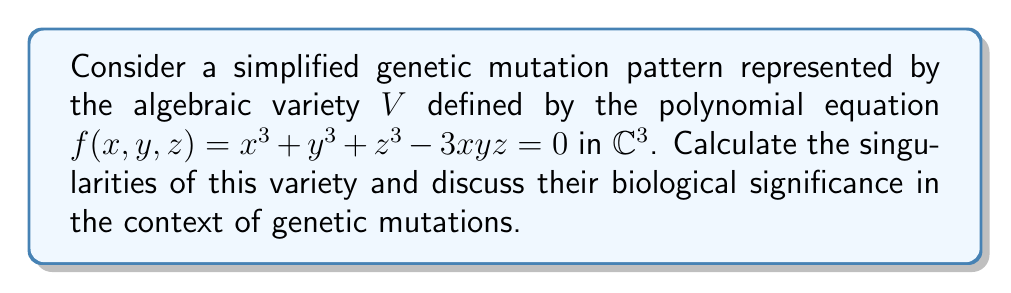Can you solve this math problem? To find the singularities of the algebraic variety $V$, we need to follow these steps:

1) Calculate the partial derivatives of $f(x,y,z)$:
   $$\frac{\partial f}{\partial x} = 3x^2 - 3yz$$
   $$\frac{\partial f}{\partial y} = 3y^2 - 3xz$$
   $$\frac{\partial f}{\partial z} = 3z^2 - 3xy$$

2) Set all partial derivatives equal to zero and solve the system of equations:
   $$3x^2 - 3yz = 0$$
   $$3y^2 - 3xz = 0$$
   $$3z^2 - 3xy = 0$$

3) Simplify the equations:
   $$x^2 = yz$$
   $$y^2 = xz$$
   $$z^2 = xy$$

4) Solve this system of equations:
   - If any of $x$, $y$, or $z$ is zero, then all must be zero to satisfy the equations.
   - If none are zero, then from $x^2 = yz$ and $z^2 = xy$, we get $x^3 = xyz$.
   - Substituting this into the original equation:
     $$x^3 + y^3 + z^3 - 3xyz = 0$$
     $$xyz + y^3 + z^3 - 3xyz = 0$$
     $$y^3 + z^3 - 2xyz = 0$$
   - Dividing by $z^3$ (assuming $z \neq 0$):
     $$(\frac{y}{z})^3 + 1 - 2(\frac{x}{z})(\frac{y}{z}) = 0$$
   - Let $u = \frac{y}{z}$ and $v = \frac{x}{z}$. Then:
     $$u^3 + 1 - 2uv = 0$$
     $$v^2 = u$$ (from $y^2 = xz$)
   - Substituting $v^2$ for $u$:
     $$(v^2)^3 + 1 - 2v^2v = 0$$
     $$v^6 + 1 - 2v^3 = 0$$
     $$(v^3 - 1)^2 = 0$$
   - Solving this:
     $$v^3 = 1$$
     $$v = 1, \omega, \omega^2$$ where $\omega$ and $\omega^2$ are the complex cube roots of unity.

5) Therefore, the singularities are:
   $$(0, 0, 0)$$
   $$(1, 1, 1)$$
   $$(\omega, \omega^2, 1)$$
   $$(\omega^2, \omega, 1)$$

In the context of genetic mutations, these singularities could represent critical points in the mutation process. The origin $(0,0,0)$ might represent a null mutation or no mutation at all. The other points, especially $(1,1,1)$, could represent balanced or stable mutations that persist in a population. The complex solutions involving $\omega$ might indicate more complex or unstable mutation patterns that are less likely to persist.
Answer: Singularities: $(0,0,0)$, $(1,1,1)$, $(\omega,\omega^2,1)$, $(\omega^2,\omega,1)$, where $\omega = e^{2\pi i/3}$. 